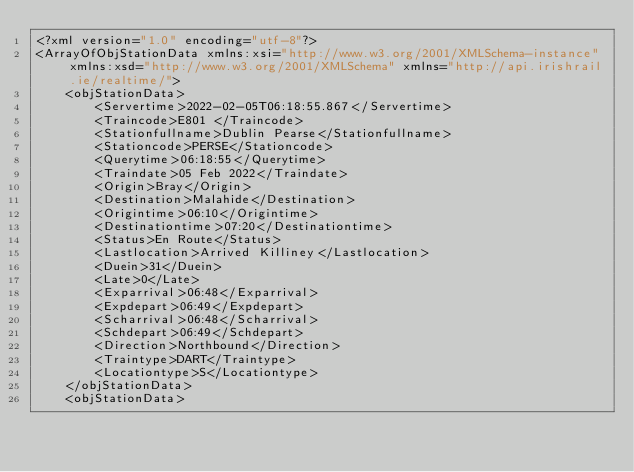Convert code to text. <code><loc_0><loc_0><loc_500><loc_500><_XML_><?xml version="1.0" encoding="utf-8"?>
<ArrayOfObjStationData xmlns:xsi="http://www.w3.org/2001/XMLSchema-instance" xmlns:xsd="http://www.w3.org/2001/XMLSchema" xmlns="http://api.irishrail.ie/realtime/">
    <objStationData>
        <Servertime>2022-02-05T06:18:55.867</Servertime>
        <Traincode>E801 </Traincode>
        <Stationfullname>Dublin Pearse</Stationfullname>
        <Stationcode>PERSE</Stationcode>
        <Querytime>06:18:55</Querytime>
        <Traindate>05 Feb 2022</Traindate>
        <Origin>Bray</Origin>
        <Destination>Malahide</Destination>
        <Origintime>06:10</Origintime>
        <Destinationtime>07:20</Destinationtime>
        <Status>En Route</Status>
        <Lastlocation>Arrived Killiney</Lastlocation>
        <Duein>31</Duein>
        <Late>0</Late>
        <Exparrival>06:48</Exparrival>
        <Expdepart>06:49</Expdepart>
        <Scharrival>06:48</Scharrival>
        <Schdepart>06:49</Schdepart>
        <Direction>Northbound</Direction>
        <Traintype>DART</Traintype>
        <Locationtype>S</Locationtype>
    </objStationData>
    <objStationData></code> 